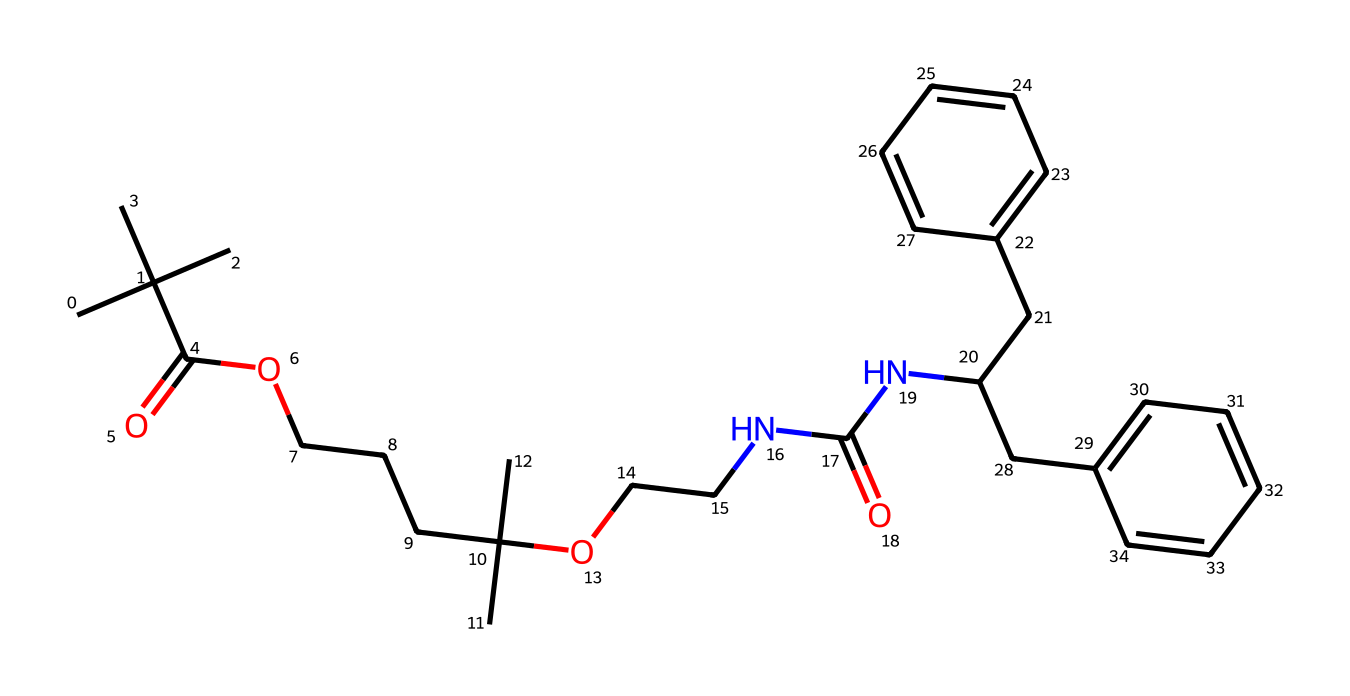What is the primary type of polymer in this chemical? The structure contains repeating units characteristic of polyurethanes, as indicated by the amide (NC(=O)) linkages present in the chain.
Answer: polyurethane How many carbon atoms are in the chemical? Counting each carbon atom within the provided SMILES representation results in a total of 25 carbon atoms.
Answer: 25 What functional groups are present in this structure? The structure contains a carboxylic acid group (C(=O)O) and amides (NC(=O)), which are critical for its properties as a polymer.
Answer: carboxylic acid, amides What is the role of the nitrogen atoms in this structure? The nitrogen atoms are part of the amide functional groups that contribute to the polymer's elasticity and strength, making it suitable for spandex.
Answer: elasticity How many rings are present in this chemical structure? There are two aromatic rings indicated by the presence of the cyclic structures (C1=CC=CC=C1 and C2=CC=CC=C2).
Answer: 2 What characteristic property does the presence of branching in the structure suggest? The branching in the structure implies a high degree of elasticity and flexibility, which is essential for the stretchable nature of spandex fabrics.
Answer: high elasticity 